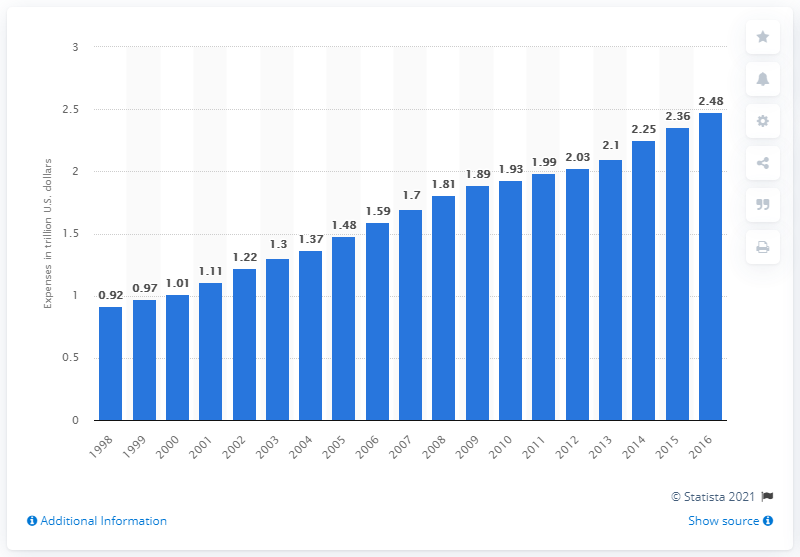List a handful of essential elements in this visual. Nonprofit organizations reported a total of $2.48 billion in expenses to the IRS in 2016. 